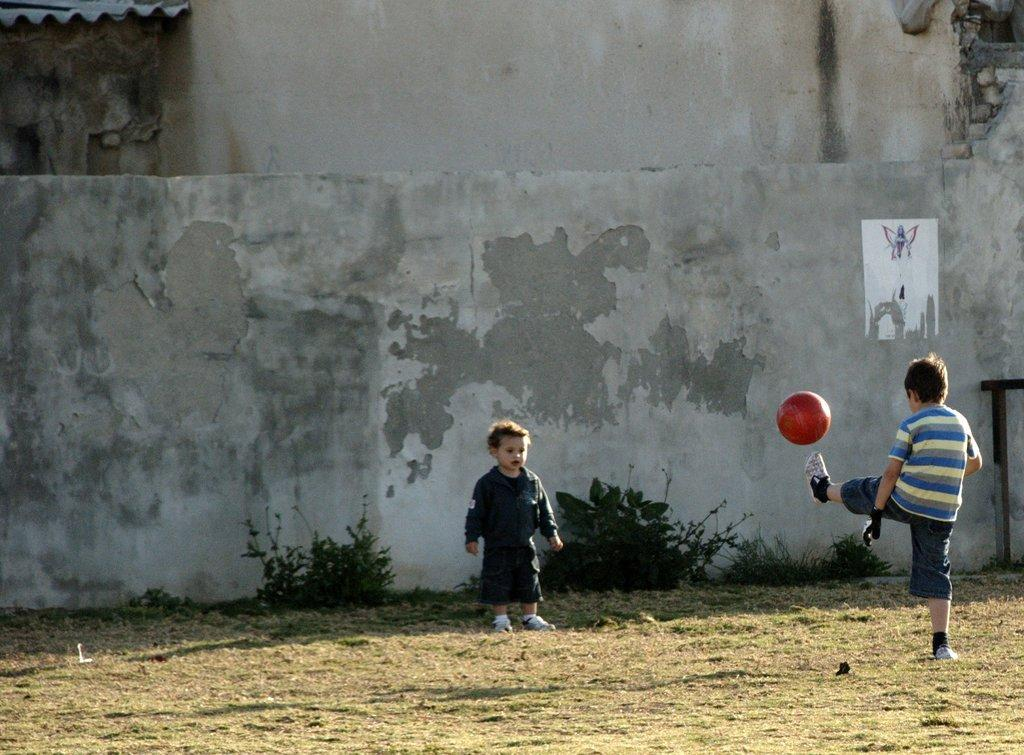What is the boy on the right side of the image doing? The boy on the right side of the image is kicking a football with his left leg. Can you describe the position of the other boy in the image? The other boy is standing in the center of the image. What can be seen in the background of the image? There is a wall in the background of the image. What type of cherry is the boy on the right side of the image holding? There is no cherry present in the image; the boy on the right side of the image is kicking a football. 